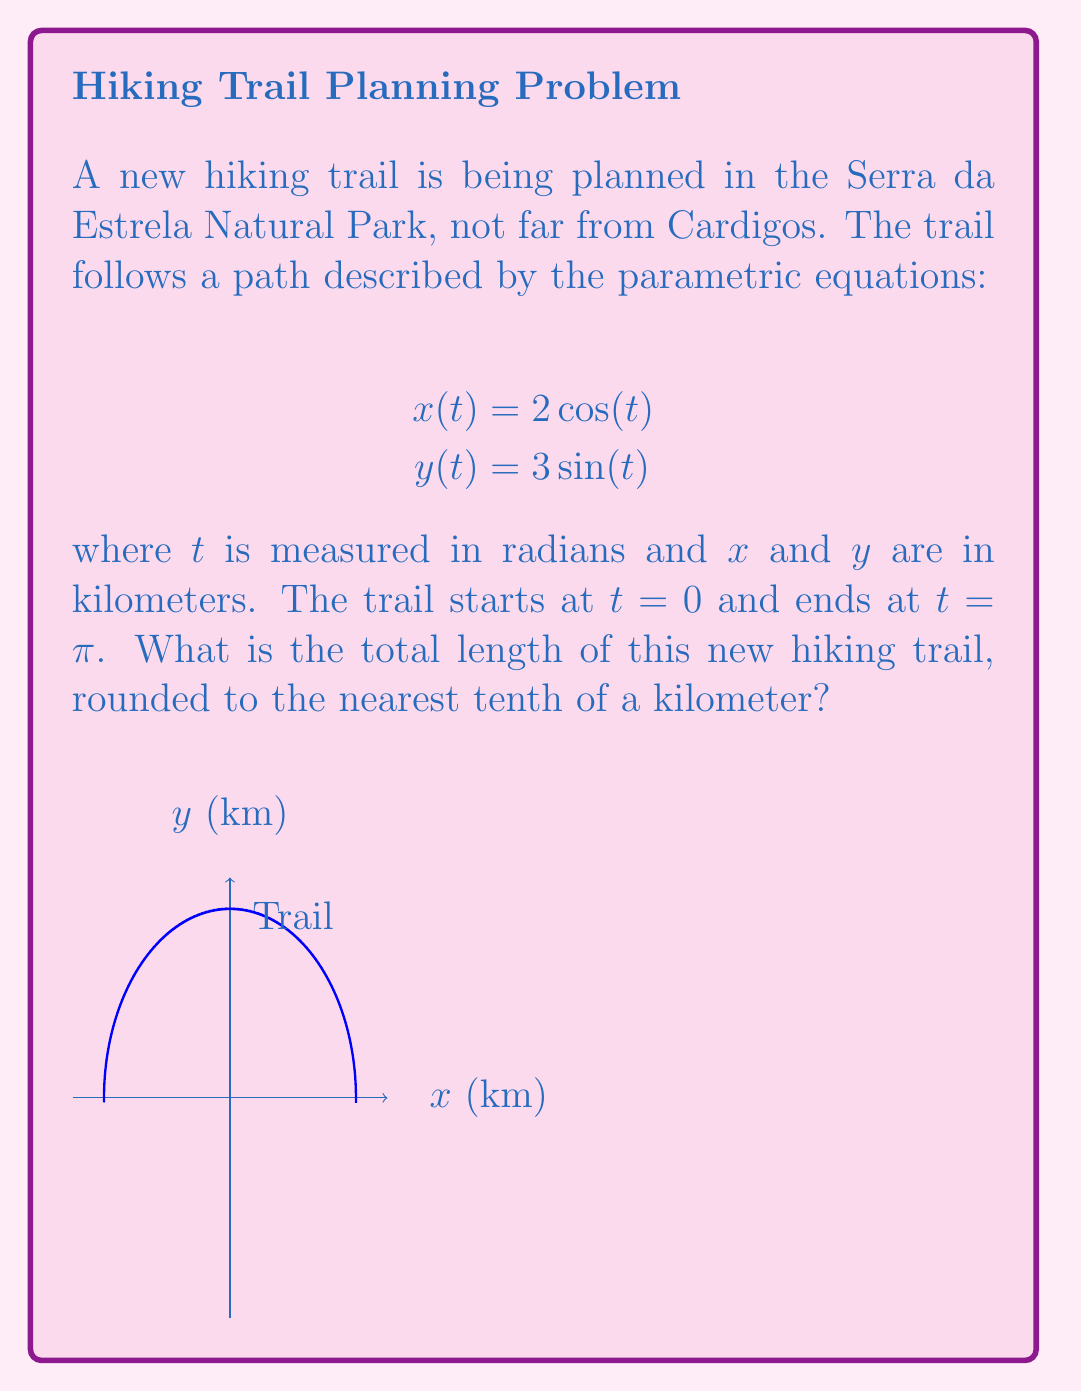Teach me how to tackle this problem. To find the length of the trail, we need to use the arc length formula for parametric equations:

$$L = \int_a^b \sqrt{\left(\frac{dx}{dt}\right)^2 + \left(\frac{dy}{dt}\right)^2} dt$$

Step 1: Find $\frac{dx}{dt}$ and $\frac{dy}{dt}$
$$\frac{dx}{dt} = -2\sin(t)$$
$$\frac{dy}{dt} = 3\cos(t)$$

Step 2: Substitute these into the arc length formula
$$L = \int_0^\pi \sqrt{(-2\sin(t))^2 + (3\cos(t))^2} dt$$

Step 3: Simplify under the square root
$$L = \int_0^\pi \sqrt{4\sin^2(t) + 9\cos^2(t)} dt$$

Step 4: Use the identity $\sin^2(t) + \cos^2(t) = 1$ to simplify further
$$L = \int_0^\pi \sqrt{4(1-\cos^2(t)) + 9\cos^2(t)} dt$$
$$L = \int_0^\pi \sqrt{4 - 4\cos^2(t) + 9\cos^2(t)} dt$$
$$L = \int_0^\pi \sqrt{4 + 5\cos^2(t)} dt$$

Step 5: This integral doesn't have an elementary antiderivative, so we need to use numerical integration. Using a calculator or computer software, we get:

$$L \approx 7.9549$$

Step 6: Rounding to the nearest tenth of a kilometer:

$$L \approx 8.0 \text{ km}$$
Answer: 8.0 km 